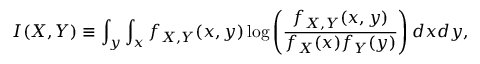Convert formula to latex. <formula><loc_0><loc_0><loc_500><loc_500>I ( X , Y ) \equiv \int _ { y } \int _ { x } f _ { X , Y } ( x , y ) \log \left ( \frac { f _ { X , Y } ( x , y ) } { f _ { X } ( x ) f _ { Y } ( y ) } \right ) d x d y ,</formula> 